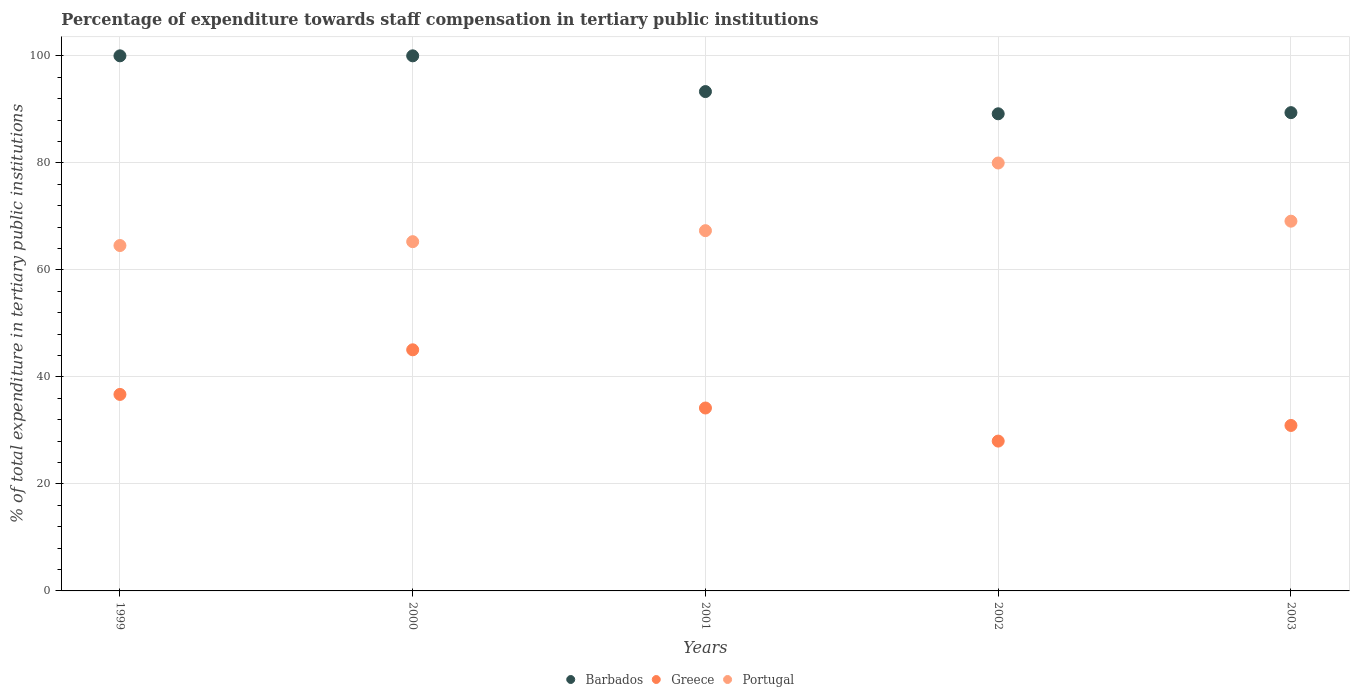What is the percentage of expenditure towards staff compensation in Barbados in 2000?
Offer a terse response. 100. Across all years, what is the maximum percentage of expenditure towards staff compensation in Barbados?
Offer a terse response. 100. Across all years, what is the minimum percentage of expenditure towards staff compensation in Barbados?
Provide a succinct answer. 89.17. What is the total percentage of expenditure towards staff compensation in Portugal in the graph?
Your response must be concise. 346.22. What is the difference between the percentage of expenditure towards staff compensation in Greece in 1999 and that in 2001?
Ensure brevity in your answer.  2.54. What is the difference between the percentage of expenditure towards staff compensation in Greece in 1999 and the percentage of expenditure towards staff compensation in Barbados in 2000?
Your answer should be compact. -63.28. What is the average percentage of expenditure towards staff compensation in Portugal per year?
Ensure brevity in your answer.  69.24. In the year 2002, what is the difference between the percentage of expenditure towards staff compensation in Barbados and percentage of expenditure towards staff compensation in Portugal?
Ensure brevity in your answer.  9.2. What is the ratio of the percentage of expenditure towards staff compensation in Barbados in 2000 to that in 2002?
Provide a succinct answer. 1.12. Is the percentage of expenditure towards staff compensation in Portugal in 2000 less than that in 2001?
Provide a short and direct response. Yes. What is the difference between the highest and the second highest percentage of expenditure towards staff compensation in Greece?
Your answer should be compact. 8.34. What is the difference between the highest and the lowest percentage of expenditure towards staff compensation in Portugal?
Provide a short and direct response. 15.42. In how many years, is the percentage of expenditure towards staff compensation in Greece greater than the average percentage of expenditure towards staff compensation in Greece taken over all years?
Your answer should be very brief. 2. Does the percentage of expenditure towards staff compensation in Barbados monotonically increase over the years?
Ensure brevity in your answer.  No. Is the percentage of expenditure towards staff compensation in Barbados strictly greater than the percentage of expenditure towards staff compensation in Greece over the years?
Your response must be concise. Yes. How many years are there in the graph?
Offer a very short reply. 5. Are the values on the major ticks of Y-axis written in scientific E-notation?
Give a very brief answer. No. Does the graph contain grids?
Your response must be concise. Yes. How are the legend labels stacked?
Offer a terse response. Horizontal. What is the title of the graph?
Your response must be concise. Percentage of expenditure towards staff compensation in tertiary public institutions. What is the label or title of the X-axis?
Give a very brief answer. Years. What is the label or title of the Y-axis?
Provide a short and direct response. % of total expenditure in tertiary public institutions. What is the % of total expenditure in tertiary public institutions of Barbados in 1999?
Provide a short and direct response. 100. What is the % of total expenditure in tertiary public institutions of Greece in 1999?
Your response must be concise. 36.72. What is the % of total expenditure in tertiary public institutions of Portugal in 1999?
Offer a terse response. 64.55. What is the % of total expenditure in tertiary public institutions in Barbados in 2000?
Keep it short and to the point. 100. What is the % of total expenditure in tertiary public institutions of Greece in 2000?
Your answer should be compact. 45.06. What is the % of total expenditure in tertiary public institutions in Portugal in 2000?
Offer a very short reply. 65.27. What is the % of total expenditure in tertiary public institutions of Barbados in 2001?
Provide a short and direct response. 93.32. What is the % of total expenditure in tertiary public institutions of Greece in 2001?
Provide a succinct answer. 34.19. What is the % of total expenditure in tertiary public institutions of Portugal in 2001?
Keep it short and to the point. 67.33. What is the % of total expenditure in tertiary public institutions in Barbados in 2002?
Offer a very short reply. 89.17. What is the % of total expenditure in tertiary public institutions in Greece in 2002?
Your response must be concise. 28. What is the % of total expenditure in tertiary public institutions of Portugal in 2002?
Offer a terse response. 79.97. What is the % of total expenditure in tertiary public institutions in Barbados in 2003?
Your answer should be compact. 89.38. What is the % of total expenditure in tertiary public institutions of Greece in 2003?
Offer a terse response. 30.92. What is the % of total expenditure in tertiary public institutions in Portugal in 2003?
Your response must be concise. 69.1. Across all years, what is the maximum % of total expenditure in tertiary public institutions in Greece?
Offer a very short reply. 45.06. Across all years, what is the maximum % of total expenditure in tertiary public institutions in Portugal?
Offer a very short reply. 79.97. Across all years, what is the minimum % of total expenditure in tertiary public institutions in Barbados?
Make the answer very short. 89.17. Across all years, what is the minimum % of total expenditure in tertiary public institutions of Greece?
Give a very brief answer. 28. Across all years, what is the minimum % of total expenditure in tertiary public institutions in Portugal?
Offer a terse response. 64.55. What is the total % of total expenditure in tertiary public institutions in Barbados in the graph?
Your response must be concise. 471.87. What is the total % of total expenditure in tertiary public institutions in Greece in the graph?
Ensure brevity in your answer.  174.89. What is the total % of total expenditure in tertiary public institutions in Portugal in the graph?
Offer a very short reply. 346.22. What is the difference between the % of total expenditure in tertiary public institutions of Greece in 1999 and that in 2000?
Your answer should be very brief. -8.34. What is the difference between the % of total expenditure in tertiary public institutions in Portugal in 1999 and that in 2000?
Make the answer very short. -0.72. What is the difference between the % of total expenditure in tertiary public institutions of Barbados in 1999 and that in 2001?
Ensure brevity in your answer.  6.68. What is the difference between the % of total expenditure in tertiary public institutions in Greece in 1999 and that in 2001?
Give a very brief answer. 2.54. What is the difference between the % of total expenditure in tertiary public institutions of Portugal in 1999 and that in 2001?
Keep it short and to the point. -2.78. What is the difference between the % of total expenditure in tertiary public institutions of Barbados in 1999 and that in 2002?
Your answer should be very brief. 10.83. What is the difference between the % of total expenditure in tertiary public institutions in Greece in 1999 and that in 2002?
Offer a very short reply. 8.72. What is the difference between the % of total expenditure in tertiary public institutions of Portugal in 1999 and that in 2002?
Provide a short and direct response. -15.42. What is the difference between the % of total expenditure in tertiary public institutions in Barbados in 1999 and that in 2003?
Provide a short and direct response. 10.62. What is the difference between the % of total expenditure in tertiary public institutions of Greece in 1999 and that in 2003?
Give a very brief answer. 5.8. What is the difference between the % of total expenditure in tertiary public institutions of Portugal in 1999 and that in 2003?
Ensure brevity in your answer.  -4.55. What is the difference between the % of total expenditure in tertiary public institutions of Barbados in 2000 and that in 2001?
Keep it short and to the point. 6.68. What is the difference between the % of total expenditure in tertiary public institutions of Greece in 2000 and that in 2001?
Ensure brevity in your answer.  10.88. What is the difference between the % of total expenditure in tertiary public institutions in Portugal in 2000 and that in 2001?
Your answer should be very brief. -2.06. What is the difference between the % of total expenditure in tertiary public institutions of Barbados in 2000 and that in 2002?
Offer a very short reply. 10.83. What is the difference between the % of total expenditure in tertiary public institutions of Greece in 2000 and that in 2002?
Give a very brief answer. 17.06. What is the difference between the % of total expenditure in tertiary public institutions of Portugal in 2000 and that in 2002?
Provide a short and direct response. -14.7. What is the difference between the % of total expenditure in tertiary public institutions of Barbados in 2000 and that in 2003?
Your response must be concise. 10.62. What is the difference between the % of total expenditure in tertiary public institutions in Greece in 2000 and that in 2003?
Provide a succinct answer. 14.14. What is the difference between the % of total expenditure in tertiary public institutions of Portugal in 2000 and that in 2003?
Keep it short and to the point. -3.83. What is the difference between the % of total expenditure in tertiary public institutions in Barbados in 2001 and that in 2002?
Provide a short and direct response. 4.15. What is the difference between the % of total expenditure in tertiary public institutions of Greece in 2001 and that in 2002?
Your response must be concise. 6.18. What is the difference between the % of total expenditure in tertiary public institutions in Portugal in 2001 and that in 2002?
Keep it short and to the point. -12.65. What is the difference between the % of total expenditure in tertiary public institutions in Barbados in 2001 and that in 2003?
Your answer should be very brief. 3.94. What is the difference between the % of total expenditure in tertiary public institutions of Greece in 2001 and that in 2003?
Your answer should be compact. 3.26. What is the difference between the % of total expenditure in tertiary public institutions of Portugal in 2001 and that in 2003?
Your answer should be very brief. -1.77. What is the difference between the % of total expenditure in tertiary public institutions of Barbados in 2002 and that in 2003?
Ensure brevity in your answer.  -0.21. What is the difference between the % of total expenditure in tertiary public institutions of Greece in 2002 and that in 2003?
Keep it short and to the point. -2.92. What is the difference between the % of total expenditure in tertiary public institutions of Portugal in 2002 and that in 2003?
Offer a terse response. 10.87. What is the difference between the % of total expenditure in tertiary public institutions in Barbados in 1999 and the % of total expenditure in tertiary public institutions in Greece in 2000?
Keep it short and to the point. 54.94. What is the difference between the % of total expenditure in tertiary public institutions of Barbados in 1999 and the % of total expenditure in tertiary public institutions of Portugal in 2000?
Offer a terse response. 34.73. What is the difference between the % of total expenditure in tertiary public institutions in Greece in 1999 and the % of total expenditure in tertiary public institutions in Portugal in 2000?
Give a very brief answer. -28.55. What is the difference between the % of total expenditure in tertiary public institutions in Barbados in 1999 and the % of total expenditure in tertiary public institutions in Greece in 2001?
Your answer should be very brief. 65.81. What is the difference between the % of total expenditure in tertiary public institutions in Barbados in 1999 and the % of total expenditure in tertiary public institutions in Portugal in 2001?
Provide a short and direct response. 32.67. What is the difference between the % of total expenditure in tertiary public institutions in Greece in 1999 and the % of total expenditure in tertiary public institutions in Portugal in 2001?
Offer a very short reply. -30.6. What is the difference between the % of total expenditure in tertiary public institutions of Barbados in 1999 and the % of total expenditure in tertiary public institutions of Greece in 2002?
Keep it short and to the point. 72. What is the difference between the % of total expenditure in tertiary public institutions in Barbados in 1999 and the % of total expenditure in tertiary public institutions in Portugal in 2002?
Offer a very short reply. 20.03. What is the difference between the % of total expenditure in tertiary public institutions in Greece in 1999 and the % of total expenditure in tertiary public institutions in Portugal in 2002?
Ensure brevity in your answer.  -43.25. What is the difference between the % of total expenditure in tertiary public institutions in Barbados in 1999 and the % of total expenditure in tertiary public institutions in Greece in 2003?
Offer a very short reply. 69.08. What is the difference between the % of total expenditure in tertiary public institutions of Barbados in 1999 and the % of total expenditure in tertiary public institutions of Portugal in 2003?
Your answer should be very brief. 30.9. What is the difference between the % of total expenditure in tertiary public institutions in Greece in 1999 and the % of total expenditure in tertiary public institutions in Portugal in 2003?
Provide a succinct answer. -32.38. What is the difference between the % of total expenditure in tertiary public institutions in Barbados in 2000 and the % of total expenditure in tertiary public institutions in Greece in 2001?
Provide a succinct answer. 65.81. What is the difference between the % of total expenditure in tertiary public institutions in Barbados in 2000 and the % of total expenditure in tertiary public institutions in Portugal in 2001?
Keep it short and to the point. 32.67. What is the difference between the % of total expenditure in tertiary public institutions in Greece in 2000 and the % of total expenditure in tertiary public institutions in Portugal in 2001?
Give a very brief answer. -22.27. What is the difference between the % of total expenditure in tertiary public institutions of Barbados in 2000 and the % of total expenditure in tertiary public institutions of Greece in 2002?
Offer a terse response. 72. What is the difference between the % of total expenditure in tertiary public institutions in Barbados in 2000 and the % of total expenditure in tertiary public institutions in Portugal in 2002?
Ensure brevity in your answer.  20.03. What is the difference between the % of total expenditure in tertiary public institutions of Greece in 2000 and the % of total expenditure in tertiary public institutions of Portugal in 2002?
Provide a succinct answer. -34.91. What is the difference between the % of total expenditure in tertiary public institutions of Barbados in 2000 and the % of total expenditure in tertiary public institutions of Greece in 2003?
Offer a terse response. 69.08. What is the difference between the % of total expenditure in tertiary public institutions of Barbados in 2000 and the % of total expenditure in tertiary public institutions of Portugal in 2003?
Ensure brevity in your answer.  30.9. What is the difference between the % of total expenditure in tertiary public institutions of Greece in 2000 and the % of total expenditure in tertiary public institutions of Portugal in 2003?
Your answer should be very brief. -24.04. What is the difference between the % of total expenditure in tertiary public institutions in Barbados in 2001 and the % of total expenditure in tertiary public institutions in Greece in 2002?
Keep it short and to the point. 65.32. What is the difference between the % of total expenditure in tertiary public institutions of Barbados in 2001 and the % of total expenditure in tertiary public institutions of Portugal in 2002?
Offer a terse response. 13.35. What is the difference between the % of total expenditure in tertiary public institutions of Greece in 2001 and the % of total expenditure in tertiary public institutions of Portugal in 2002?
Provide a short and direct response. -45.79. What is the difference between the % of total expenditure in tertiary public institutions in Barbados in 2001 and the % of total expenditure in tertiary public institutions in Greece in 2003?
Make the answer very short. 62.4. What is the difference between the % of total expenditure in tertiary public institutions of Barbados in 2001 and the % of total expenditure in tertiary public institutions of Portugal in 2003?
Ensure brevity in your answer.  24.22. What is the difference between the % of total expenditure in tertiary public institutions in Greece in 2001 and the % of total expenditure in tertiary public institutions in Portugal in 2003?
Provide a succinct answer. -34.91. What is the difference between the % of total expenditure in tertiary public institutions in Barbados in 2002 and the % of total expenditure in tertiary public institutions in Greece in 2003?
Provide a short and direct response. 58.25. What is the difference between the % of total expenditure in tertiary public institutions of Barbados in 2002 and the % of total expenditure in tertiary public institutions of Portugal in 2003?
Your answer should be compact. 20.07. What is the difference between the % of total expenditure in tertiary public institutions in Greece in 2002 and the % of total expenditure in tertiary public institutions in Portugal in 2003?
Give a very brief answer. -41.1. What is the average % of total expenditure in tertiary public institutions in Barbados per year?
Keep it short and to the point. 94.37. What is the average % of total expenditure in tertiary public institutions of Greece per year?
Give a very brief answer. 34.98. What is the average % of total expenditure in tertiary public institutions in Portugal per year?
Ensure brevity in your answer.  69.24. In the year 1999, what is the difference between the % of total expenditure in tertiary public institutions in Barbados and % of total expenditure in tertiary public institutions in Greece?
Provide a succinct answer. 63.28. In the year 1999, what is the difference between the % of total expenditure in tertiary public institutions in Barbados and % of total expenditure in tertiary public institutions in Portugal?
Give a very brief answer. 35.45. In the year 1999, what is the difference between the % of total expenditure in tertiary public institutions of Greece and % of total expenditure in tertiary public institutions of Portugal?
Your answer should be compact. -27.83. In the year 2000, what is the difference between the % of total expenditure in tertiary public institutions of Barbados and % of total expenditure in tertiary public institutions of Greece?
Offer a terse response. 54.94. In the year 2000, what is the difference between the % of total expenditure in tertiary public institutions in Barbados and % of total expenditure in tertiary public institutions in Portugal?
Ensure brevity in your answer.  34.73. In the year 2000, what is the difference between the % of total expenditure in tertiary public institutions in Greece and % of total expenditure in tertiary public institutions in Portugal?
Make the answer very short. -20.21. In the year 2001, what is the difference between the % of total expenditure in tertiary public institutions of Barbados and % of total expenditure in tertiary public institutions of Greece?
Your response must be concise. 59.14. In the year 2001, what is the difference between the % of total expenditure in tertiary public institutions of Barbados and % of total expenditure in tertiary public institutions of Portugal?
Give a very brief answer. 25.99. In the year 2001, what is the difference between the % of total expenditure in tertiary public institutions of Greece and % of total expenditure in tertiary public institutions of Portugal?
Your answer should be very brief. -33.14. In the year 2002, what is the difference between the % of total expenditure in tertiary public institutions of Barbados and % of total expenditure in tertiary public institutions of Greece?
Ensure brevity in your answer.  61.17. In the year 2002, what is the difference between the % of total expenditure in tertiary public institutions of Barbados and % of total expenditure in tertiary public institutions of Portugal?
Provide a succinct answer. 9.2. In the year 2002, what is the difference between the % of total expenditure in tertiary public institutions of Greece and % of total expenditure in tertiary public institutions of Portugal?
Your response must be concise. -51.97. In the year 2003, what is the difference between the % of total expenditure in tertiary public institutions in Barbados and % of total expenditure in tertiary public institutions in Greece?
Provide a short and direct response. 58.46. In the year 2003, what is the difference between the % of total expenditure in tertiary public institutions in Barbados and % of total expenditure in tertiary public institutions in Portugal?
Give a very brief answer. 20.28. In the year 2003, what is the difference between the % of total expenditure in tertiary public institutions in Greece and % of total expenditure in tertiary public institutions in Portugal?
Offer a terse response. -38.18. What is the ratio of the % of total expenditure in tertiary public institutions of Barbados in 1999 to that in 2000?
Give a very brief answer. 1. What is the ratio of the % of total expenditure in tertiary public institutions in Greece in 1999 to that in 2000?
Make the answer very short. 0.81. What is the ratio of the % of total expenditure in tertiary public institutions in Barbados in 1999 to that in 2001?
Your response must be concise. 1.07. What is the ratio of the % of total expenditure in tertiary public institutions of Greece in 1999 to that in 2001?
Your answer should be compact. 1.07. What is the ratio of the % of total expenditure in tertiary public institutions in Portugal in 1999 to that in 2001?
Offer a terse response. 0.96. What is the ratio of the % of total expenditure in tertiary public institutions in Barbados in 1999 to that in 2002?
Provide a succinct answer. 1.12. What is the ratio of the % of total expenditure in tertiary public institutions of Greece in 1999 to that in 2002?
Offer a very short reply. 1.31. What is the ratio of the % of total expenditure in tertiary public institutions of Portugal in 1999 to that in 2002?
Ensure brevity in your answer.  0.81. What is the ratio of the % of total expenditure in tertiary public institutions in Barbados in 1999 to that in 2003?
Your answer should be compact. 1.12. What is the ratio of the % of total expenditure in tertiary public institutions of Greece in 1999 to that in 2003?
Your response must be concise. 1.19. What is the ratio of the % of total expenditure in tertiary public institutions of Portugal in 1999 to that in 2003?
Your answer should be very brief. 0.93. What is the ratio of the % of total expenditure in tertiary public institutions of Barbados in 2000 to that in 2001?
Provide a short and direct response. 1.07. What is the ratio of the % of total expenditure in tertiary public institutions of Greece in 2000 to that in 2001?
Ensure brevity in your answer.  1.32. What is the ratio of the % of total expenditure in tertiary public institutions of Portugal in 2000 to that in 2001?
Give a very brief answer. 0.97. What is the ratio of the % of total expenditure in tertiary public institutions in Barbados in 2000 to that in 2002?
Offer a very short reply. 1.12. What is the ratio of the % of total expenditure in tertiary public institutions in Greece in 2000 to that in 2002?
Provide a succinct answer. 1.61. What is the ratio of the % of total expenditure in tertiary public institutions of Portugal in 2000 to that in 2002?
Your answer should be compact. 0.82. What is the ratio of the % of total expenditure in tertiary public institutions of Barbados in 2000 to that in 2003?
Keep it short and to the point. 1.12. What is the ratio of the % of total expenditure in tertiary public institutions of Greece in 2000 to that in 2003?
Offer a very short reply. 1.46. What is the ratio of the % of total expenditure in tertiary public institutions in Portugal in 2000 to that in 2003?
Your answer should be very brief. 0.94. What is the ratio of the % of total expenditure in tertiary public institutions in Barbados in 2001 to that in 2002?
Make the answer very short. 1.05. What is the ratio of the % of total expenditure in tertiary public institutions of Greece in 2001 to that in 2002?
Ensure brevity in your answer.  1.22. What is the ratio of the % of total expenditure in tertiary public institutions in Portugal in 2001 to that in 2002?
Make the answer very short. 0.84. What is the ratio of the % of total expenditure in tertiary public institutions of Barbados in 2001 to that in 2003?
Offer a terse response. 1.04. What is the ratio of the % of total expenditure in tertiary public institutions in Greece in 2001 to that in 2003?
Provide a succinct answer. 1.11. What is the ratio of the % of total expenditure in tertiary public institutions in Portugal in 2001 to that in 2003?
Keep it short and to the point. 0.97. What is the ratio of the % of total expenditure in tertiary public institutions of Barbados in 2002 to that in 2003?
Give a very brief answer. 1. What is the ratio of the % of total expenditure in tertiary public institutions in Greece in 2002 to that in 2003?
Your answer should be very brief. 0.91. What is the ratio of the % of total expenditure in tertiary public institutions in Portugal in 2002 to that in 2003?
Offer a very short reply. 1.16. What is the difference between the highest and the second highest % of total expenditure in tertiary public institutions of Barbados?
Make the answer very short. 0. What is the difference between the highest and the second highest % of total expenditure in tertiary public institutions of Greece?
Make the answer very short. 8.34. What is the difference between the highest and the second highest % of total expenditure in tertiary public institutions of Portugal?
Your answer should be compact. 10.87. What is the difference between the highest and the lowest % of total expenditure in tertiary public institutions of Barbados?
Offer a very short reply. 10.83. What is the difference between the highest and the lowest % of total expenditure in tertiary public institutions in Greece?
Offer a very short reply. 17.06. What is the difference between the highest and the lowest % of total expenditure in tertiary public institutions of Portugal?
Offer a terse response. 15.42. 